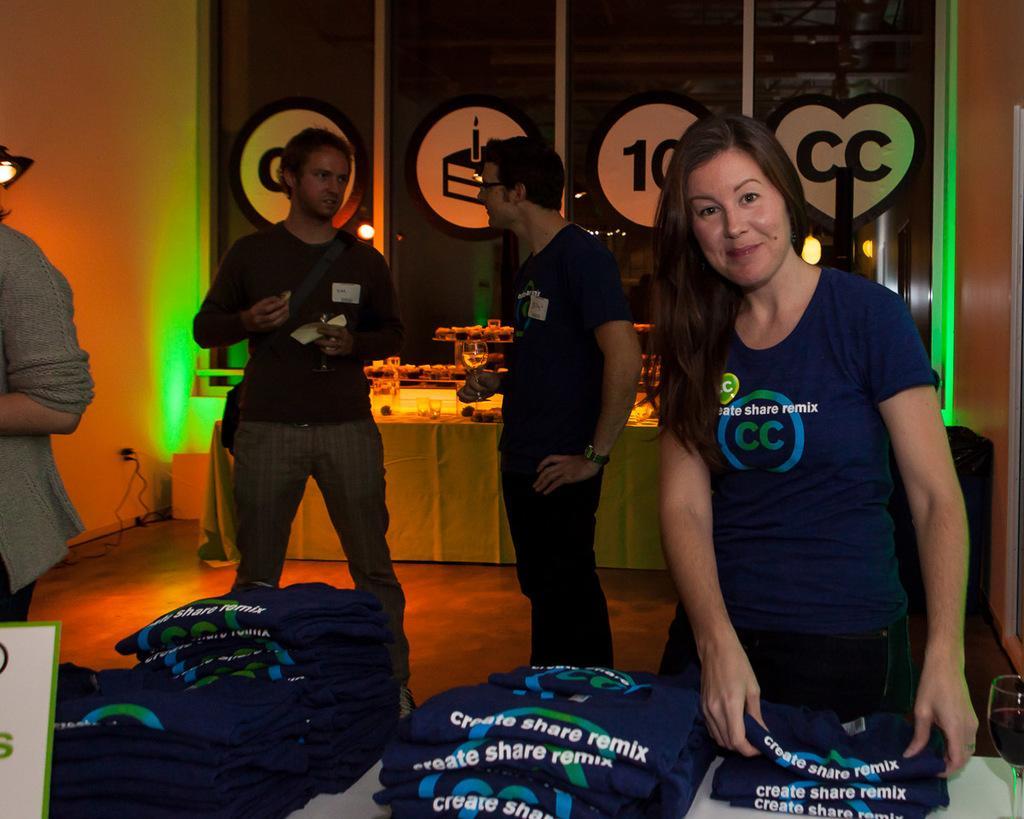Can you describe this image briefly? In this image we can see few people and few people are holding some objects in their hands. There are many objects placed on the table behind the people. There are many clothes placed on the table at the bottom of the image. There are few reflections on the glasses of the building. 